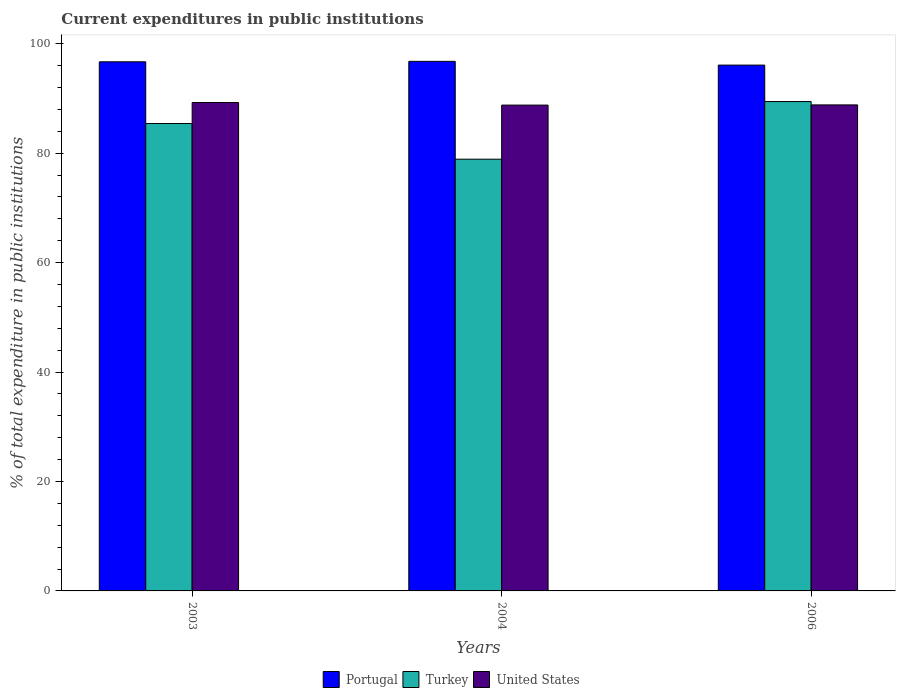How many groups of bars are there?
Your answer should be very brief. 3. Are the number of bars per tick equal to the number of legend labels?
Ensure brevity in your answer.  Yes. How many bars are there on the 3rd tick from the right?
Your response must be concise. 3. What is the current expenditures in public institutions in Turkey in 2004?
Offer a terse response. 78.91. Across all years, what is the maximum current expenditures in public institutions in Turkey?
Make the answer very short. 89.45. Across all years, what is the minimum current expenditures in public institutions in Portugal?
Make the answer very short. 96.11. In which year was the current expenditures in public institutions in Turkey minimum?
Your response must be concise. 2004. What is the total current expenditures in public institutions in Turkey in the graph?
Your answer should be very brief. 253.79. What is the difference between the current expenditures in public institutions in Portugal in 2003 and that in 2006?
Your answer should be compact. 0.6. What is the difference between the current expenditures in public institutions in Portugal in 2003 and the current expenditures in public institutions in United States in 2004?
Your answer should be very brief. 7.91. What is the average current expenditures in public institutions in Turkey per year?
Your response must be concise. 84.6. In the year 2003, what is the difference between the current expenditures in public institutions in Turkey and current expenditures in public institutions in United States?
Offer a very short reply. -3.84. In how many years, is the current expenditures in public institutions in Turkey greater than 88 %?
Your response must be concise. 1. What is the ratio of the current expenditures in public institutions in Portugal in 2003 to that in 2004?
Provide a succinct answer. 1. Is the current expenditures in public institutions in United States in 2003 less than that in 2004?
Keep it short and to the point. No. What is the difference between the highest and the second highest current expenditures in public institutions in Portugal?
Give a very brief answer. 0.08. What is the difference between the highest and the lowest current expenditures in public institutions in Turkey?
Provide a short and direct response. 10.54. What does the 3rd bar from the right in 2003 represents?
Provide a short and direct response. Portugal. Are all the bars in the graph horizontal?
Provide a short and direct response. No. How many years are there in the graph?
Provide a short and direct response. 3. What is the difference between two consecutive major ticks on the Y-axis?
Provide a succinct answer. 20. Does the graph contain any zero values?
Your answer should be very brief. No. Does the graph contain grids?
Your response must be concise. No. Where does the legend appear in the graph?
Your answer should be compact. Bottom center. How many legend labels are there?
Keep it short and to the point. 3. What is the title of the graph?
Provide a short and direct response. Current expenditures in public institutions. Does "High income: nonOECD" appear as one of the legend labels in the graph?
Your answer should be very brief. No. What is the label or title of the Y-axis?
Provide a succinct answer. % of total expenditure in public institutions. What is the % of total expenditure in public institutions in Portugal in 2003?
Make the answer very short. 96.71. What is the % of total expenditure in public institutions in Turkey in 2003?
Make the answer very short. 85.43. What is the % of total expenditure in public institutions of United States in 2003?
Provide a short and direct response. 89.27. What is the % of total expenditure in public institutions in Portugal in 2004?
Your response must be concise. 96.79. What is the % of total expenditure in public institutions in Turkey in 2004?
Give a very brief answer. 78.91. What is the % of total expenditure in public institutions of United States in 2004?
Your response must be concise. 88.8. What is the % of total expenditure in public institutions in Portugal in 2006?
Offer a terse response. 96.11. What is the % of total expenditure in public institutions of Turkey in 2006?
Ensure brevity in your answer.  89.45. What is the % of total expenditure in public institutions of United States in 2006?
Make the answer very short. 88.83. Across all years, what is the maximum % of total expenditure in public institutions of Portugal?
Make the answer very short. 96.79. Across all years, what is the maximum % of total expenditure in public institutions in Turkey?
Offer a terse response. 89.45. Across all years, what is the maximum % of total expenditure in public institutions in United States?
Give a very brief answer. 89.27. Across all years, what is the minimum % of total expenditure in public institutions of Portugal?
Provide a short and direct response. 96.11. Across all years, what is the minimum % of total expenditure in public institutions of Turkey?
Give a very brief answer. 78.91. Across all years, what is the minimum % of total expenditure in public institutions of United States?
Give a very brief answer. 88.8. What is the total % of total expenditure in public institutions of Portugal in the graph?
Provide a short and direct response. 289.61. What is the total % of total expenditure in public institutions of Turkey in the graph?
Offer a very short reply. 253.79. What is the total % of total expenditure in public institutions of United States in the graph?
Make the answer very short. 266.9. What is the difference between the % of total expenditure in public institutions in Portugal in 2003 and that in 2004?
Offer a very short reply. -0.08. What is the difference between the % of total expenditure in public institutions in Turkey in 2003 and that in 2004?
Your answer should be compact. 6.52. What is the difference between the % of total expenditure in public institutions in United States in 2003 and that in 2004?
Your answer should be compact. 0.47. What is the difference between the % of total expenditure in public institutions of Portugal in 2003 and that in 2006?
Give a very brief answer. 0.6. What is the difference between the % of total expenditure in public institutions of Turkey in 2003 and that in 2006?
Ensure brevity in your answer.  -4.02. What is the difference between the % of total expenditure in public institutions in United States in 2003 and that in 2006?
Your answer should be compact. 0.43. What is the difference between the % of total expenditure in public institutions in Portugal in 2004 and that in 2006?
Provide a succinct answer. 0.69. What is the difference between the % of total expenditure in public institutions of Turkey in 2004 and that in 2006?
Offer a terse response. -10.54. What is the difference between the % of total expenditure in public institutions in United States in 2004 and that in 2006?
Provide a succinct answer. -0.04. What is the difference between the % of total expenditure in public institutions in Portugal in 2003 and the % of total expenditure in public institutions in Turkey in 2004?
Offer a very short reply. 17.8. What is the difference between the % of total expenditure in public institutions of Portugal in 2003 and the % of total expenditure in public institutions of United States in 2004?
Give a very brief answer. 7.91. What is the difference between the % of total expenditure in public institutions of Turkey in 2003 and the % of total expenditure in public institutions of United States in 2004?
Your answer should be compact. -3.37. What is the difference between the % of total expenditure in public institutions in Portugal in 2003 and the % of total expenditure in public institutions in Turkey in 2006?
Keep it short and to the point. 7.26. What is the difference between the % of total expenditure in public institutions of Portugal in 2003 and the % of total expenditure in public institutions of United States in 2006?
Provide a succinct answer. 7.88. What is the difference between the % of total expenditure in public institutions in Turkey in 2003 and the % of total expenditure in public institutions in United States in 2006?
Provide a short and direct response. -3.4. What is the difference between the % of total expenditure in public institutions of Portugal in 2004 and the % of total expenditure in public institutions of Turkey in 2006?
Make the answer very short. 7.35. What is the difference between the % of total expenditure in public institutions of Portugal in 2004 and the % of total expenditure in public institutions of United States in 2006?
Your answer should be very brief. 7.96. What is the difference between the % of total expenditure in public institutions of Turkey in 2004 and the % of total expenditure in public institutions of United States in 2006?
Ensure brevity in your answer.  -9.92. What is the average % of total expenditure in public institutions of Portugal per year?
Keep it short and to the point. 96.54. What is the average % of total expenditure in public institutions in Turkey per year?
Offer a very short reply. 84.6. What is the average % of total expenditure in public institutions of United States per year?
Provide a succinct answer. 88.97. In the year 2003, what is the difference between the % of total expenditure in public institutions in Portugal and % of total expenditure in public institutions in Turkey?
Your answer should be very brief. 11.28. In the year 2003, what is the difference between the % of total expenditure in public institutions in Portugal and % of total expenditure in public institutions in United States?
Provide a succinct answer. 7.44. In the year 2003, what is the difference between the % of total expenditure in public institutions in Turkey and % of total expenditure in public institutions in United States?
Make the answer very short. -3.84. In the year 2004, what is the difference between the % of total expenditure in public institutions of Portugal and % of total expenditure in public institutions of Turkey?
Make the answer very short. 17.88. In the year 2004, what is the difference between the % of total expenditure in public institutions in Portugal and % of total expenditure in public institutions in United States?
Offer a very short reply. 8. In the year 2004, what is the difference between the % of total expenditure in public institutions in Turkey and % of total expenditure in public institutions in United States?
Provide a succinct answer. -9.89. In the year 2006, what is the difference between the % of total expenditure in public institutions in Portugal and % of total expenditure in public institutions in Turkey?
Your answer should be very brief. 6.66. In the year 2006, what is the difference between the % of total expenditure in public institutions in Portugal and % of total expenditure in public institutions in United States?
Offer a terse response. 7.27. In the year 2006, what is the difference between the % of total expenditure in public institutions of Turkey and % of total expenditure in public institutions of United States?
Provide a short and direct response. 0.61. What is the ratio of the % of total expenditure in public institutions in Turkey in 2003 to that in 2004?
Give a very brief answer. 1.08. What is the ratio of the % of total expenditure in public institutions of United States in 2003 to that in 2004?
Your answer should be very brief. 1.01. What is the ratio of the % of total expenditure in public institutions in Portugal in 2003 to that in 2006?
Keep it short and to the point. 1.01. What is the ratio of the % of total expenditure in public institutions of Turkey in 2003 to that in 2006?
Give a very brief answer. 0.96. What is the ratio of the % of total expenditure in public institutions in Portugal in 2004 to that in 2006?
Make the answer very short. 1.01. What is the ratio of the % of total expenditure in public institutions of Turkey in 2004 to that in 2006?
Your answer should be compact. 0.88. What is the ratio of the % of total expenditure in public institutions of United States in 2004 to that in 2006?
Provide a short and direct response. 1. What is the difference between the highest and the second highest % of total expenditure in public institutions in Portugal?
Make the answer very short. 0.08. What is the difference between the highest and the second highest % of total expenditure in public institutions in Turkey?
Keep it short and to the point. 4.02. What is the difference between the highest and the second highest % of total expenditure in public institutions in United States?
Make the answer very short. 0.43. What is the difference between the highest and the lowest % of total expenditure in public institutions of Portugal?
Your answer should be compact. 0.69. What is the difference between the highest and the lowest % of total expenditure in public institutions of Turkey?
Make the answer very short. 10.54. What is the difference between the highest and the lowest % of total expenditure in public institutions of United States?
Give a very brief answer. 0.47. 